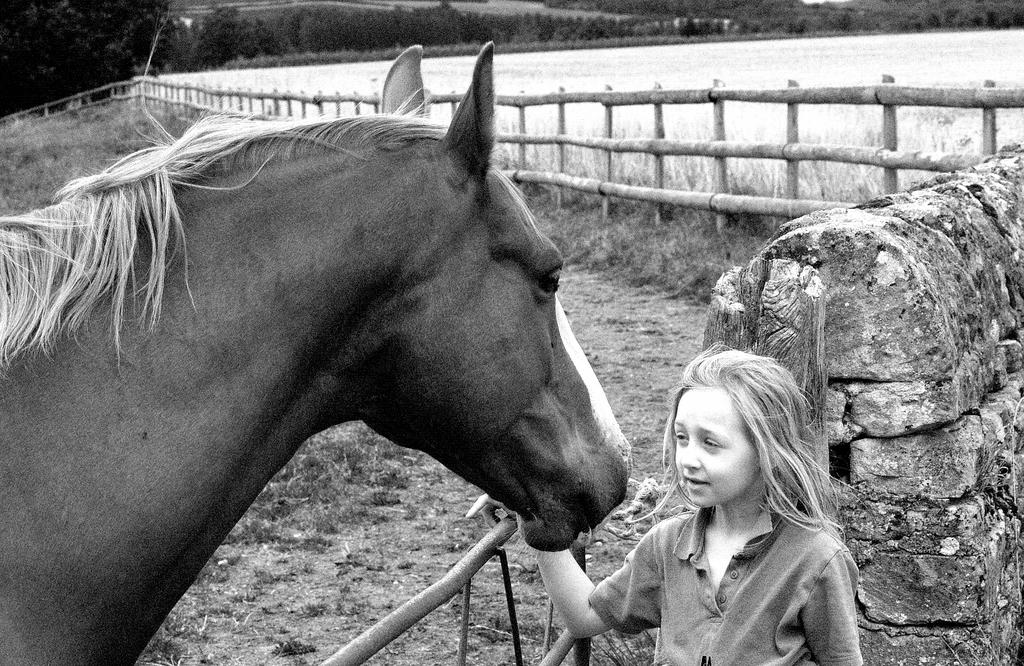What animal is present in the image? There is a horse in the image. What is the girl doing in the image? The girl is touching the horse. What type of environment is visible in the background of the image? There is grass and trees in the background of the image. What type of wax can be seen melting on the horse's back in the image? There is no wax present in the image; it features a horse and a girl touching it. What type of alarm is going off in the background of the image? There is no alarm present in the image; it features a horse, a girl touching it, and a grassy background with trees. 